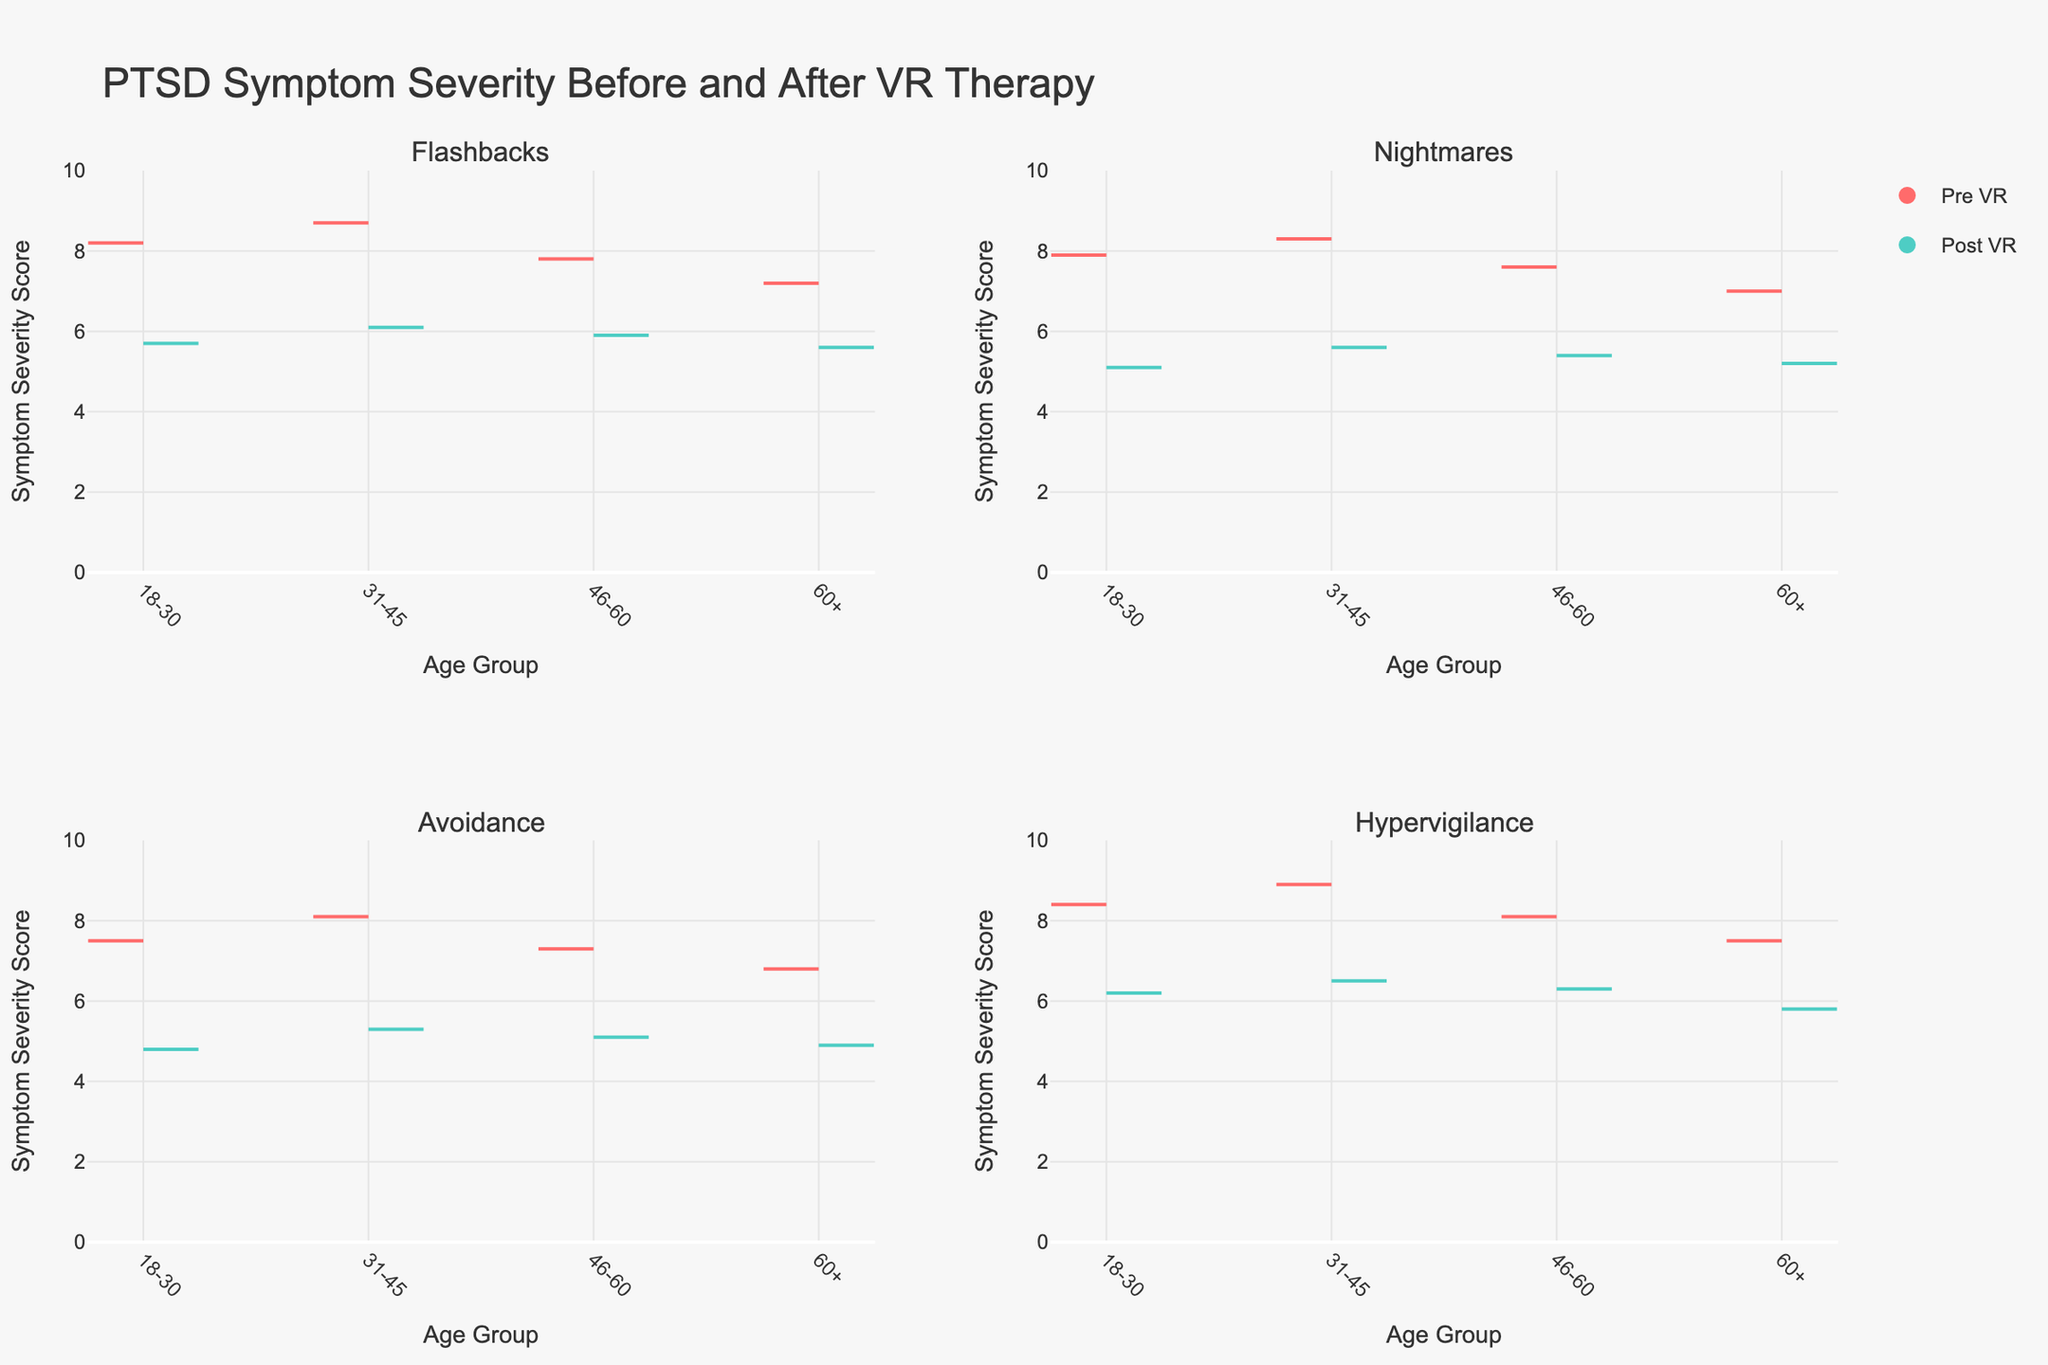what is the title of the plot? The title is typically displayed at the top center of the figure. In this case, it states "PTSD Symptom Severity Before and After VR Therapy".
Answer: PTSD Symptom Severity Before and After VR Therapy What age group has the largest drop in Flashbacks severity after VR therapy? To find the largest drop, compare the pre and post VR therapy scores for Flashbacks across all age groups. The drop is the difference between the pre and post scores. For 18-30, the drop is 8.2 - 5.7 = 2.5. For 31-45, it's 8.7 - 6.1 = 2.6. For 46-60, it's 7.8 - 5.9 = 1.9. For 60+, it's 7.2 - 5.6 = 1.6. Hence, the 31-45 age group has the largest drop.
Answer: 31-45 Which symptom has the smallest change in severity for the 60+ age group after VR therapy? To determine this, examine the differences between pre and post VR therapy scores for all symptoms in age group 60+. For Flashbacks, the change is 7.2 - 5.6 = 1.6. For Nightmares, it's 7.0 - 5.2 = 1.8. For Avoidance, it's 6.8 - 4.9 = 1.9. For Hypervigilance, it's 7.5 - 5.8 = 1.7. The smallest change is therefore for Flashbacks.
Answer: Flashbacks Which age group had the highest pre-therapy score for Hypervigilance? Refer to the violin plots for Hypervigilance in each age group to note the pre-therapy scores. They are 8.4 (18-30), 8.9 (31-45), 8.1 (46-60), and 7.5 (60+). Hence, the 31-45 age group had the highest pre-therapy score.
Answer: 31-45 What is the average post-therapy severity score for Nightmares across all age groups? Calculate the post-therapy scores for Nightmares for each age group and find the average. The scores are 5.1 (18-30), 5.6 (31-45), 5.4 (46-60), and 5.2 (60+). The average is (5.1 + 5.6 + 5.4 + 5.2) / 4 = 5.325.
Answer: 5.325 What is the median pre-therapy severity score for Avoidance across different age groups? List the pre-therapy scores for Avoidance: 7.5 (18-30), 8.1 (31-45), 7.3 (46-60), and 6.8 (60+). Sorting these scores, we get 6.8, 7.3, 7.5, and 8.1. The median of these four scores is the average of the two middle numbers, (7.3 + 7.5) / 2 = 7.4.
Answer: 7.4 